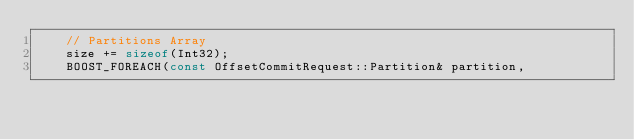Convert code to text. <code><loc_0><loc_0><loc_500><loc_500><_C_>    // Partitions Array
    size += sizeof(Int32);
    BOOST_FOREACH(const OffsetCommitRequest::Partition& partition,</code> 